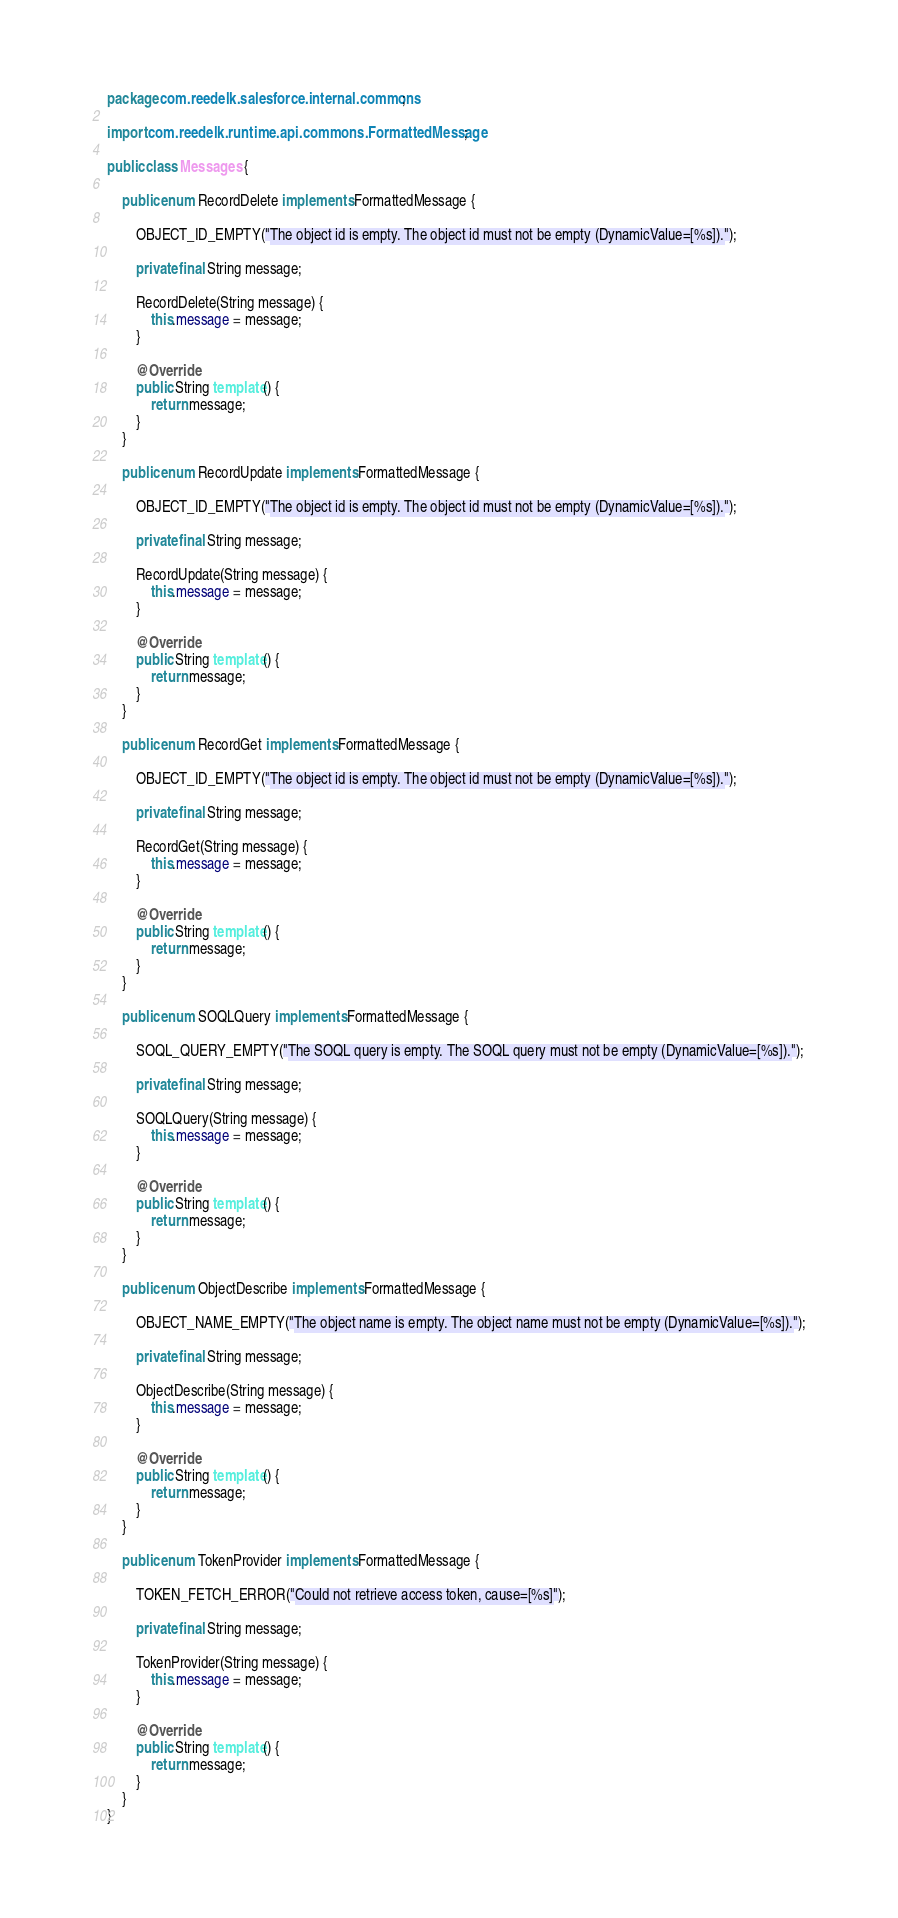<code> <loc_0><loc_0><loc_500><loc_500><_Java_>package com.reedelk.salesforce.internal.commons;

import com.reedelk.runtime.api.commons.FormattedMessage;

public class Messages {

    public enum RecordDelete implements FormattedMessage {

        OBJECT_ID_EMPTY("The object id is empty. The object id must not be empty (DynamicValue=[%s]).");

        private final String message;

        RecordDelete(String message) {
            this.message = message;
        }

        @Override
        public String template() {
            return message;
        }
    }

    public enum RecordUpdate implements FormattedMessage {

        OBJECT_ID_EMPTY("The object id is empty. The object id must not be empty (DynamicValue=[%s]).");

        private final String message;

        RecordUpdate(String message) {
            this.message = message;
        }

        @Override
        public String template() {
            return message;
        }
    }

    public enum RecordGet implements FormattedMessage {

        OBJECT_ID_EMPTY("The object id is empty. The object id must not be empty (DynamicValue=[%s]).");

        private final String message;

        RecordGet(String message) {
            this.message = message;
        }

        @Override
        public String template() {
            return message;
        }
    }

    public enum SOQLQuery implements FormattedMessage {

        SOQL_QUERY_EMPTY("The SOQL query is empty. The SOQL query must not be empty (DynamicValue=[%s]).");

        private final String message;

        SOQLQuery(String message) {
            this.message = message;
        }

        @Override
        public String template() {
            return message;
        }
    }

    public enum ObjectDescribe implements FormattedMessage {

        OBJECT_NAME_EMPTY("The object name is empty. The object name must not be empty (DynamicValue=[%s]).");

        private final String message;

        ObjectDescribe(String message) {
            this.message = message;
        }

        @Override
        public String template() {
            return message;
        }
    }

    public enum TokenProvider implements FormattedMessage {

        TOKEN_FETCH_ERROR("Could not retrieve access token, cause=[%s]");

        private final String message;

        TokenProvider(String message) {
            this.message = message;
        }

        @Override
        public String template() {
            return message;
        }
    }
}
</code> 